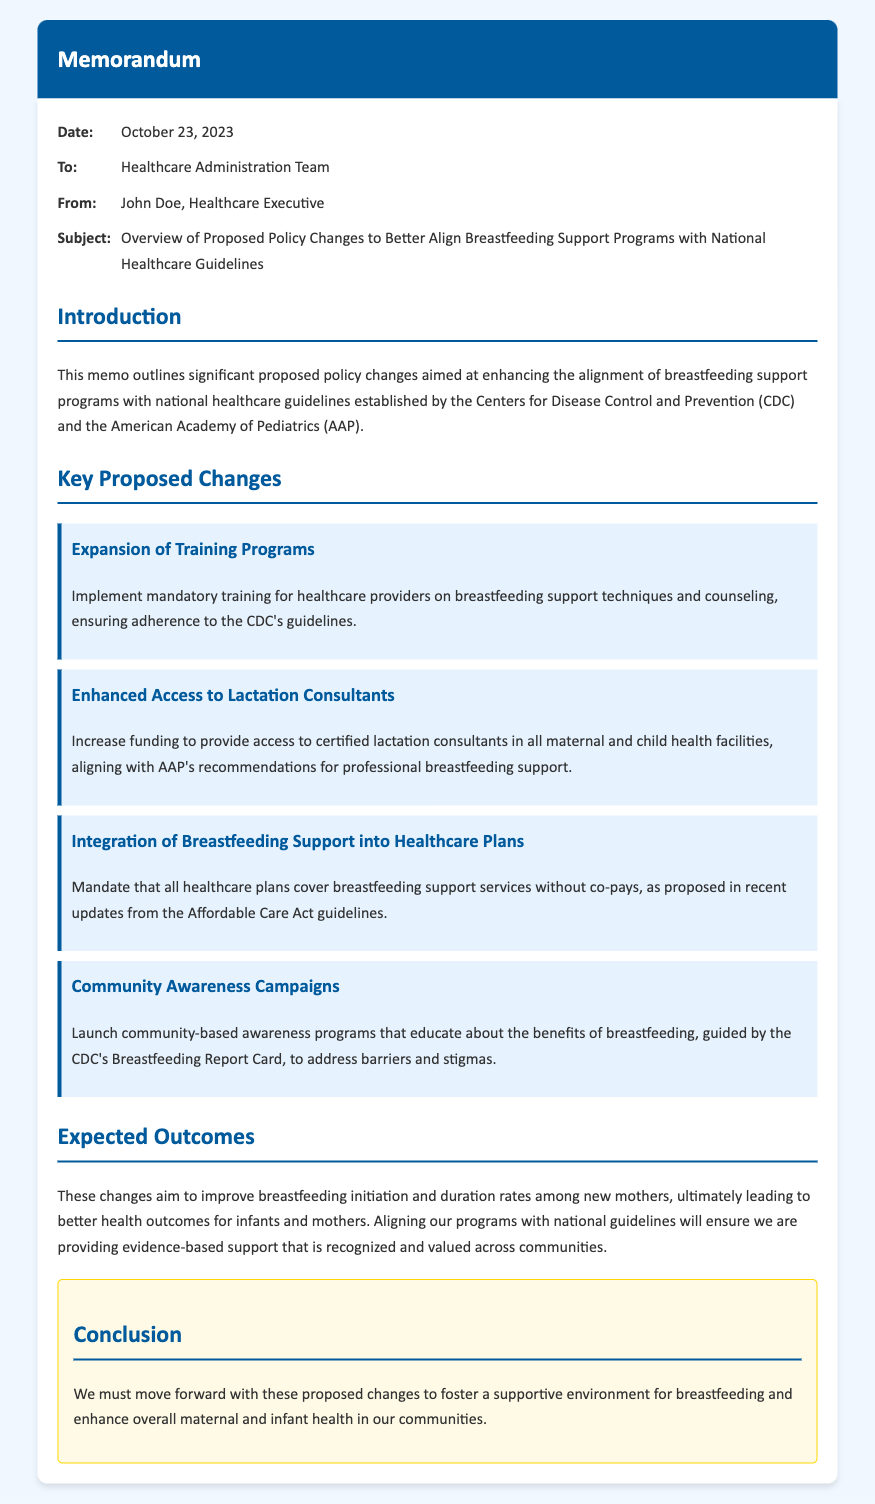What is the date of the memo? The date of the memo is specified in the memo details section.
Answer: October 23, 2023 Who is the sender of the memo? The sender of the memo is mentioned in the "From" section of the memo details.
Answer: John Doe What is one key proposed change mentioned? Key proposed changes are outlined in the corresponding section of the memo.
Answer: Expansion of Training Programs What is the purpose of the community awareness campaigns? The rationale for the community awareness campaigns is detailed in their description.
Answer: Educate about the benefits of breastfeeding Which two organizations' guidelines are referenced in the memo? The memo mentions the guidelines from these organizations in the introduction section.
Answer: CDC and AAP What is the expected outcome of the proposed changes? The expected outcomes are addressed in the outcomes section of the memo.
Answer: Improve breastfeeding initiation and duration rates What type of memo is this? The structure and content suggest the type of the document is revealed in the memo header.
Answer: Memorandum What will be mandated regarding healthcare plans? The memo specifies requirements for healthcare plans in one of the proposed changes.
Answer: Cover breastfeeding support services without co-pays 